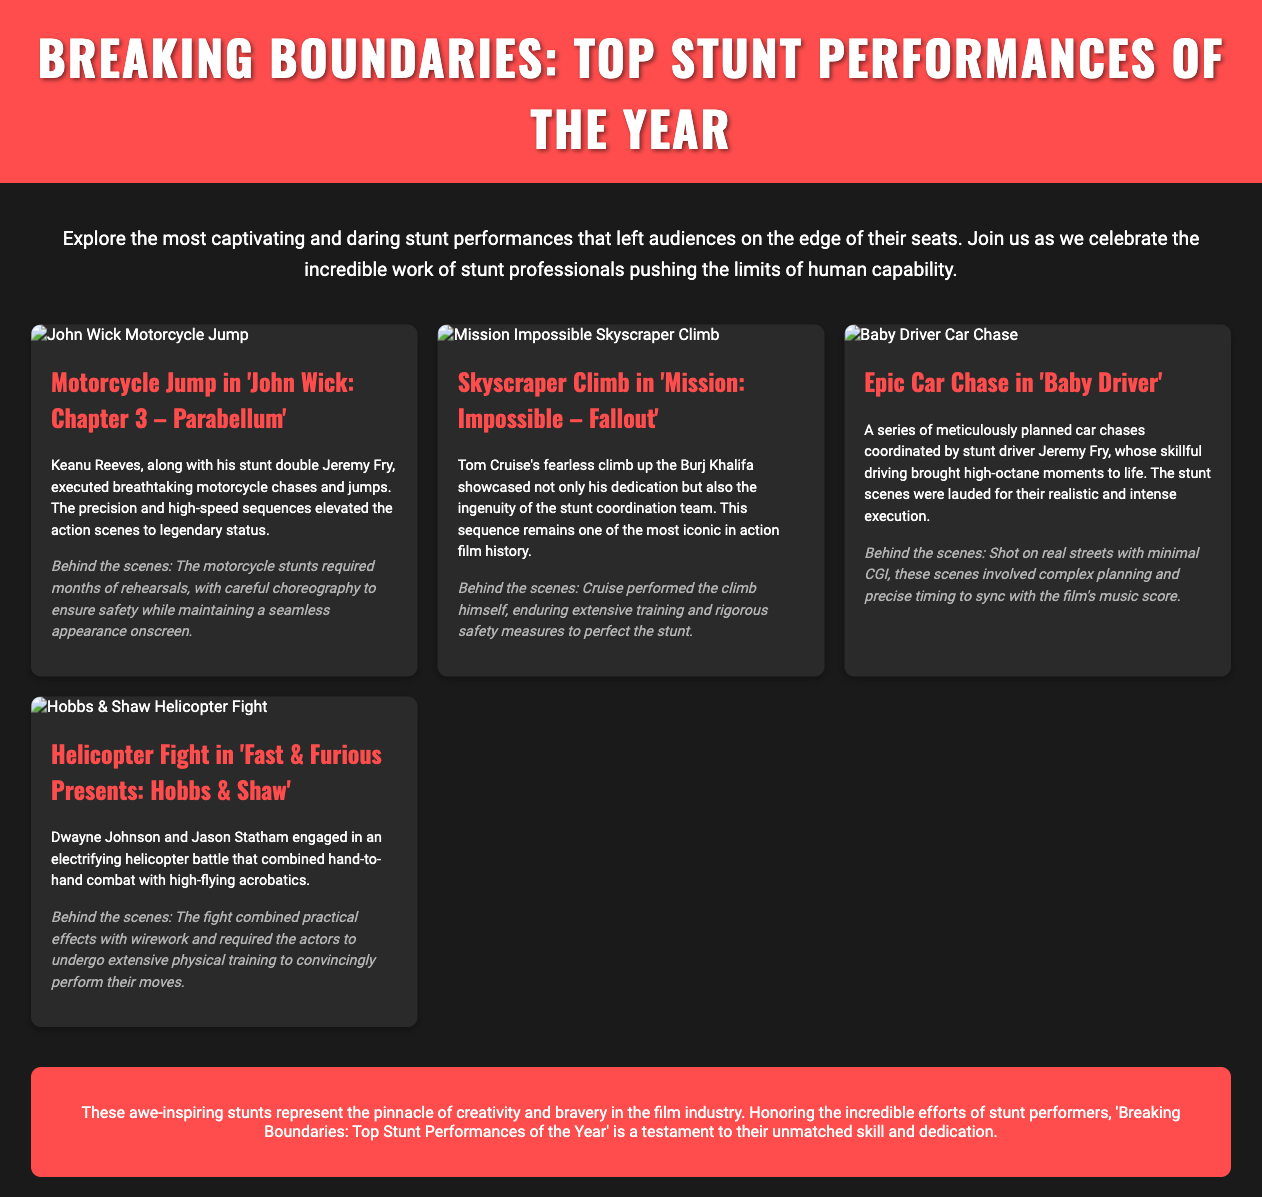what is the title of the flyer? The title is prominently displayed at the top of the flyer, indicating the main theme of the document.
Answer: Breaking Boundaries: Top Stunt Performances of the Year how many stunts are showcased in the flyer? The flyer presents a total of four stunning stunt performances based on the descriptions provided.
Answer: 4 who is the stunt double for Keanu Reeves in 'John Wick: Chapter 3 – Parabellum'? The flyer specifies the name of Keanu Reeves's stunt double in the performance description section.
Answer: Jeremy Fry which film features a skyscraper climb? The specific film is mentioned in the title of the stunt description, outlining a notable stunt scene.
Answer: Mission: Impossible – Fallout what type of vehicle is involved in the car chase from 'Baby Driver'? The document describes the primary action related to the stunt focusing on the vehicle used during the notable chase.
Answer: Car who performed the helicopter fight in 'Fast & Furious Presents: Hobbs & Shaw'? The names of the main actors involved in the stunt are listed in the description provided in the document.
Answer: Dwayne Johnson and Jason Statham what is a common element mentioned in the behind-the-scenes sections? These sections provide insight into what contributed to the success and safety of the stunts performed.
Answer: Extensive training what color is the background of the flyer? The color theme is represented in the design specifications of the flyer, indicating the aesthetic choice made.
Answer: Black 